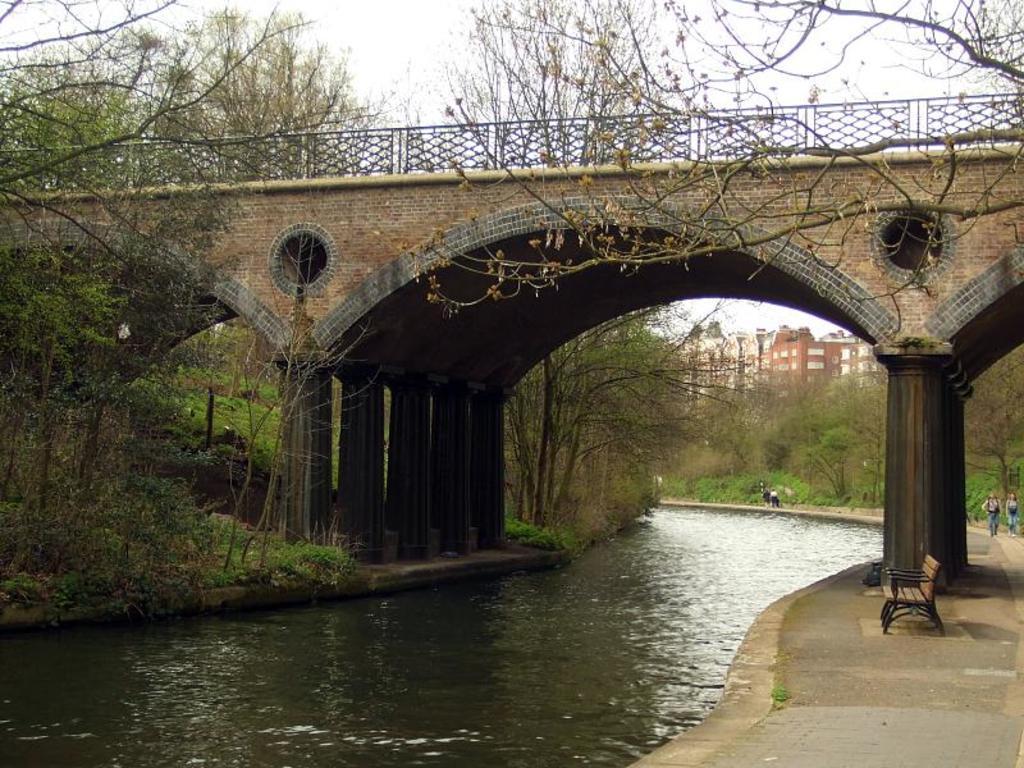Can you describe this image briefly? In this picture we can see a bench on the ground, two people, water, bridge, trees, buildings and in the background we can see the sky. 